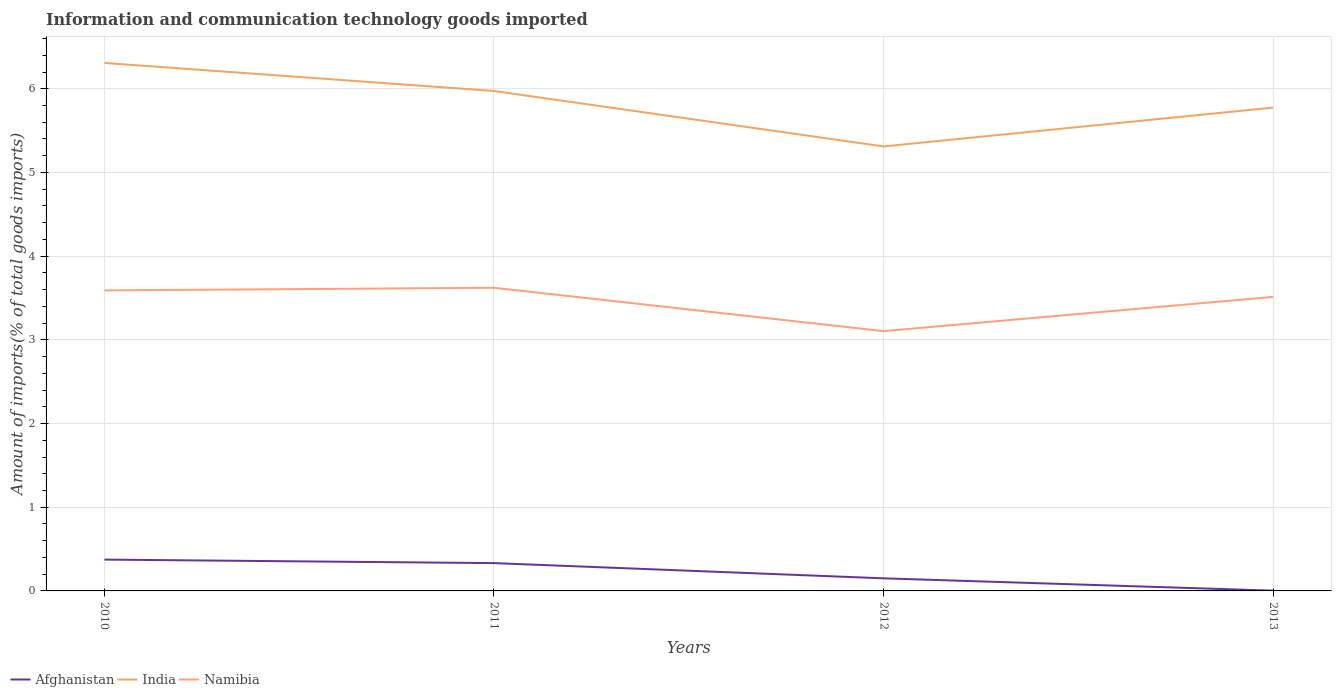How many different coloured lines are there?
Offer a very short reply. 3. Across all years, what is the maximum amount of goods imported in Afghanistan?
Ensure brevity in your answer.  0. In which year was the amount of goods imported in Afghanistan maximum?
Offer a terse response. 2013. What is the total amount of goods imported in India in the graph?
Give a very brief answer. 0.2. What is the difference between the highest and the second highest amount of goods imported in Namibia?
Your response must be concise. 0.52. What is the difference between the highest and the lowest amount of goods imported in Afghanistan?
Offer a terse response. 2. Is the amount of goods imported in Afghanistan strictly greater than the amount of goods imported in India over the years?
Your answer should be compact. Yes. How many years are there in the graph?
Make the answer very short. 4. Are the values on the major ticks of Y-axis written in scientific E-notation?
Your response must be concise. No. Does the graph contain grids?
Your answer should be compact. Yes. Where does the legend appear in the graph?
Give a very brief answer. Bottom left. How are the legend labels stacked?
Your response must be concise. Horizontal. What is the title of the graph?
Your answer should be very brief. Information and communication technology goods imported. What is the label or title of the Y-axis?
Provide a succinct answer. Amount of imports(% of total goods imports). What is the Amount of imports(% of total goods imports) in Afghanistan in 2010?
Your response must be concise. 0.37. What is the Amount of imports(% of total goods imports) of India in 2010?
Your response must be concise. 6.31. What is the Amount of imports(% of total goods imports) of Namibia in 2010?
Give a very brief answer. 3.59. What is the Amount of imports(% of total goods imports) in Afghanistan in 2011?
Provide a short and direct response. 0.33. What is the Amount of imports(% of total goods imports) of India in 2011?
Make the answer very short. 5.97. What is the Amount of imports(% of total goods imports) in Namibia in 2011?
Provide a succinct answer. 3.62. What is the Amount of imports(% of total goods imports) in Afghanistan in 2012?
Make the answer very short. 0.15. What is the Amount of imports(% of total goods imports) in India in 2012?
Provide a succinct answer. 5.31. What is the Amount of imports(% of total goods imports) in Namibia in 2012?
Give a very brief answer. 3.1. What is the Amount of imports(% of total goods imports) of Afghanistan in 2013?
Provide a succinct answer. 0. What is the Amount of imports(% of total goods imports) in India in 2013?
Offer a very short reply. 5.78. What is the Amount of imports(% of total goods imports) in Namibia in 2013?
Your answer should be very brief. 3.51. Across all years, what is the maximum Amount of imports(% of total goods imports) in Afghanistan?
Keep it short and to the point. 0.37. Across all years, what is the maximum Amount of imports(% of total goods imports) of India?
Provide a short and direct response. 6.31. Across all years, what is the maximum Amount of imports(% of total goods imports) of Namibia?
Your answer should be compact. 3.62. Across all years, what is the minimum Amount of imports(% of total goods imports) of Afghanistan?
Your answer should be very brief. 0. Across all years, what is the minimum Amount of imports(% of total goods imports) in India?
Your answer should be very brief. 5.31. Across all years, what is the minimum Amount of imports(% of total goods imports) of Namibia?
Give a very brief answer. 3.1. What is the total Amount of imports(% of total goods imports) in Afghanistan in the graph?
Give a very brief answer. 0.86. What is the total Amount of imports(% of total goods imports) in India in the graph?
Your answer should be compact. 23.37. What is the total Amount of imports(% of total goods imports) in Namibia in the graph?
Offer a very short reply. 13.83. What is the difference between the Amount of imports(% of total goods imports) in Afghanistan in 2010 and that in 2011?
Your answer should be compact. 0.04. What is the difference between the Amount of imports(% of total goods imports) in India in 2010 and that in 2011?
Make the answer very short. 0.33. What is the difference between the Amount of imports(% of total goods imports) in Namibia in 2010 and that in 2011?
Provide a short and direct response. -0.03. What is the difference between the Amount of imports(% of total goods imports) of Afghanistan in 2010 and that in 2012?
Keep it short and to the point. 0.22. What is the difference between the Amount of imports(% of total goods imports) of Namibia in 2010 and that in 2012?
Ensure brevity in your answer.  0.49. What is the difference between the Amount of imports(% of total goods imports) of Afghanistan in 2010 and that in 2013?
Keep it short and to the point. 0.37. What is the difference between the Amount of imports(% of total goods imports) of India in 2010 and that in 2013?
Make the answer very short. 0.53. What is the difference between the Amount of imports(% of total goods imports) in Namibia in 2010 and that in 2013?
Give a very brief answer. 0.08. What is the difference between the Amount of imports(% of total goods imports) of Afghanistan in 2011 and that in 2012?
Offer a very short reply. 0.18. What is the difference between the Amount of imports(% of total goods imports) in India in 2011 and that in 2012?
Make the answer very short. 0.66. What is the difference between the Amount of imports(% of total goods imports) in Namibia in 2011 and that in 2012?
Make the answer very short. 0.52. What is the difference between the Amount of imports(% of total goods imports) of Afghanistan in 2011 and that in 2013?
Offer a very short reply. 0.33. What is the difference between the Amount of imports(% of total goods imports) of India in 2011 and that in 2013?
Provide a succinct answer. 0.2. What is the difference between the Amount of imports(% of total goods imports) of Namibia in 2011 and that in 2013?
Ensure brevity in your answer.  0.11. What is the difference between the Amount of imports(% of total goods imports) of Afghanistan in 2012 and that in 2013?
Keep it short and to the point. 0.15. What is the difference between the Amount of imports(% of total goods imports) of India in 2012 and that in 2013?
Ensure brevity in your answer.  -0.46. What is the difference between the Amount of imports(% of total goods imports) of Namibia in 2012 and that in 2013?
Your response must be concise. -0.41. What is the difference between the Amount of imports(% of total goods imports) in Afghanistan in 2010 and the Amount of imports(% of total goods imports) in India in 2011?
Ensure brevity in your answer.  -5.6. What is the difference between the Amount of imports(% of total goods imports) of Afghanistan in 2010 and the Amount of imports(% of total goods imports) of Namibia in 2011?
Provide a short and direct response. -3.25. What is the difference between the Amount of imports(% of total goods imports) in India in 2010 and the Amount of imports(% of total goods imports) in Namibia in 2011?
Ensure brevity in your answer.  2.69. What is the difference between the Amount of imports(% of total goods imports) of Afghanistan in 2010 and the Amount of imports(% of total goods imports) of India in 2012?
Make the answer very short. -4.94. What is the difference between the Amount of imports(% of total goods imports) of Afghanistan in 2010 and the Amount of imports(% of total goods imports) of Namibia in 2012?
Provide a short and direct response. -2.73. What is the difference between the Amount of imports(% of total goods imports) of India in 2010 and the Amount of imports(% of total goods imports) of Namibia in 2012?
Your answer should be very brief. 3.2. What is the difference between the Amount of imports(% of total goods imports) in Afghanistan in 2010 and the Amount of imports(% of total goods imports) in India in 2013?
Provide a short and direct response. -5.4. What is the difference between the Amount of imports(% of total goods imports) of Afghanistan in 2010 and the Amount of imports(% of total goods imports) of Namibia in 2013?
Your answer should be very brief. -3.14. What is the difference between the Amount of imports(% of total goods imports) in India in 2010 and the Amount of imports(% of total goods imports) in Namibia in 2013?
Give a very brief answer. 2.8. What is the difference between the Amount of imports(% of total goods imports) of Afghanistan in 2011 and the Amount of imports(% of total goods imports) of India in 2012?
Your answer should be very brief. -4.98. What is the difference between the Amount of imports(% of total goods imports) of Afghanistan in 2011 and the Amount of imports(% of total goods imports) of Namibia in 2012?
Keep it short and to the point. -2.77. What is the difference between the Amount of imports(% of total goods imports) of India in 2011 and the Amount of imports(% of total goods imports) of Namibia in 2012?
Offer a terse response. 2.87. What is the difference between the Amount of imports(% of total goods imports) in Afghanistan in 2011 and the Amount of imports(% of total goods imports) in India in 2013?
Offer a terse response. -5.44. What is the difference between the Amount of imports(% of total goods imports) in Afghanistan in 2011 and the Amount of imports(% of total goods imports) in Namibia in 2013?
Your answer should be compact. -3.18. What is the difference between the Amount of imports(% of total goods imports) in India in 2011 and the Amount of imports(% of total goods imports) in Namibia in 2013?
Make the answer very short. 2.46. What is the difference between the Amount of imports(% of total goods imports) of Afghanistan in 2012 and the Amount of imports(% of total goods imports) of India in 2013?
Your answer should be very brief. -5.62. What is the difference between the Amount of imports(% of total goods imports) of Afghanistan in 2012 and the Amount of imports(% of total goods imports) of Namibia in 2013?
Keep it short and to the point. -3.36. What is the difference between the Amount of imports(% of total goods imports) in India in 2012 and the Amount of imports(% of total goods imports) in Namibia in 2013?
Your answer should be very brief. 1.8. What is the average Amount of imports(% of total goods imports) in Afghanistan per year?
Your answer should be very brief. 0.22. What is the average Amount of imports(% of total goods imports) of India per year?
Make the answer very short. 5.84. What is the average Amount of imports(% of total goods imports) of Namibia per year?
Provide a succinct answer. 3.46. In the year 2010, what is the difference between the Amount of imports(% of total goods imports) of Afghanistan and Amount of imports(% of total goods imports) of India?
Your answer should be very brief. -5.93. In the year 2010, what is the difference between the Amount of imports(% of total goods imports) of Afghanistan and Amount of imports(% of total goods imports) of Namibia?
Give a very brief answer. -3.22. In the year 2010, what is the difference between the Amount of imports(% of total goods imports) of India and Amount of imports(% of total goods imports) of Namibia?
Make the answer very short. 2.72. In the year 2011, what is the difference between the Amount of imports(% of total goods imports) of Afghanistan and Amount of imports(% of total goods imports) of India?
Offer a terse response. -5.64. In the year 2011, what is the difference between the Amount of imports(% of total goods imports) in Afghanistan and Amount of imports(% of total goods imports) in Namibia?
Provide a short and direct response. -3.29. In the year 2011, what is the difference between the Amount of imports(% of total goods imports) of India and Amount of imports(% of total goods imports) of Namibia?
Give a very brief answer. 2.35. In the year 2012, what is the difference between the Amount of imports(% of total goods imports) in Afghanistan and Amount of imports(% of total goods imports) in India?
Give a very brief answer. -5.16. In the year 2012, what is the difference between the Amount of imports(% of total goods imports) in Afghanistan and Amount of imports(% of total goods imports) in Namibia?
Give a very brief answer. -2.95. In the year 2012, what is the difference between the Amount of imports(% of total goods imports) of India and Amount of imports(% of total goods imports) of Namibia?
Your response must be concise. 2.21. In the year 2013, what is the difference between the Amount of imports(% of total goods imports) of Afghanistan and Amount of imports(% of total goods imports) of India?
Offer a very short reply. -5.77. In the year 2013, what is the difference between the Amount of imports(% of total goods imports) of Afghanistan and Amount of imports(% of total goods imports) of Namibia?
Provide a short and direct response. -3.51. In the year 2013, what is the difference between the Amount of imports(% of total goods imports) of India and Amount of imports(% of total goods imports) of Namibia?
Ensure brevity in your answer.  2.26. What is the ratio of the Amount of imports(% of total goods imports) of Afghanistan in 2010 to that in 2011?
Keep it short and to the point. 1.13. What is the ratio of the Amount of imports(% of total goods imports) of India in 2010 to that in 2011?
Offer a very short reply. 1.06. What is the ratio of the Amount of imports(% of total goods imports) in Namibia in 2010 to that in 2011?
Your answer should be very brief. 0.99. What is the ratio of the Amount of imports(% of total goods imports) of Afghanistan in 2010 to that in 2012?
Your answer should be very brief. 2.49. What is the ratio of the Amount of imports(% of total goods imports) in India in 2010 to that in 2012?
Your answer should be compact. 1.19. What is the ratio of the Amount of imports(% of total goods imports) in Namibia in 2010 to that in 2012?
Provide a short and direct response. 1.16. What is the ratio of the Amount of imports(% of total goods imports) in Afghanistan in 2010 to that in 2013?
Give a very brief answer. 112.81. What is the ratio of the Amount of imports(% of total goods imports) of India in 2010 to that in 2013?
Your answer should be very brief. 1.09. What is the ratio of the Amount of imports(% of total goods imports) of Afghanistan in 2011 to that in 2012?
Keep it short and to the point. 2.21. What is the ratio of the Amount of imports(% of total goods imports) of India in 2011 to that in 2012?
Provide a succinct answer. 1.12. What is the ratio of the Amount of imports(% of total goods imports) of Namibia in 2011 to that in 2012?
Provide a short and direct response. 1.17. What is the ratio of the Amount of imports(% of total goods imports) in Afghanistan in 2011 to that in 2013?
Provide a succinct answer. 100.13. What is the ratio of the Amount of imports(% of total goods imports) of India in 2011 to that in 2013?
Keep it short and to the point. 1.03. What is the ratio of the Amount of imports(% of total goods imports) of Namibia in 2011 to that in 2013?
Your answer should be compact. 1.03. What is the ratio of the Amount of imports(% of total goods imports) in Afghanistan in 2012 to that in 2013?
Offer a very short reply. 45.33. What is the ratio of the Amount of imports(% of total goods imports) in India in 2012 to that in 2013?
Give a very brief answer. 0.92. What is the ratio of the Amount of imports(% of total goods imports) of Namibia in 2012 to that in 2013?
Your response must be concise. 0.88. What is the difference between the highest and the second highest Amount of imports(% of total goods imports) of Afghanistan?
Ensure brevity in your answer.  0.04. What is the difference between the highest and the second highest Amount of imports(% of total goods imports) of India?
Keep it short and to the point. 0.33. What is the difference between the highest and the second highest Amount of imports(% of total goods imports) in Namibia?
Keep it short and to the point. 0.03. What is the difference between the highest and the lowest Amount of imports(% of total goods imports) of Afghanistan?
Offer a very short reply. 0.37. What is the difference between the highest and the lowest Amount of imports(% of total goods imports) of Namibia?
Your answer should be compact. 0.52. 